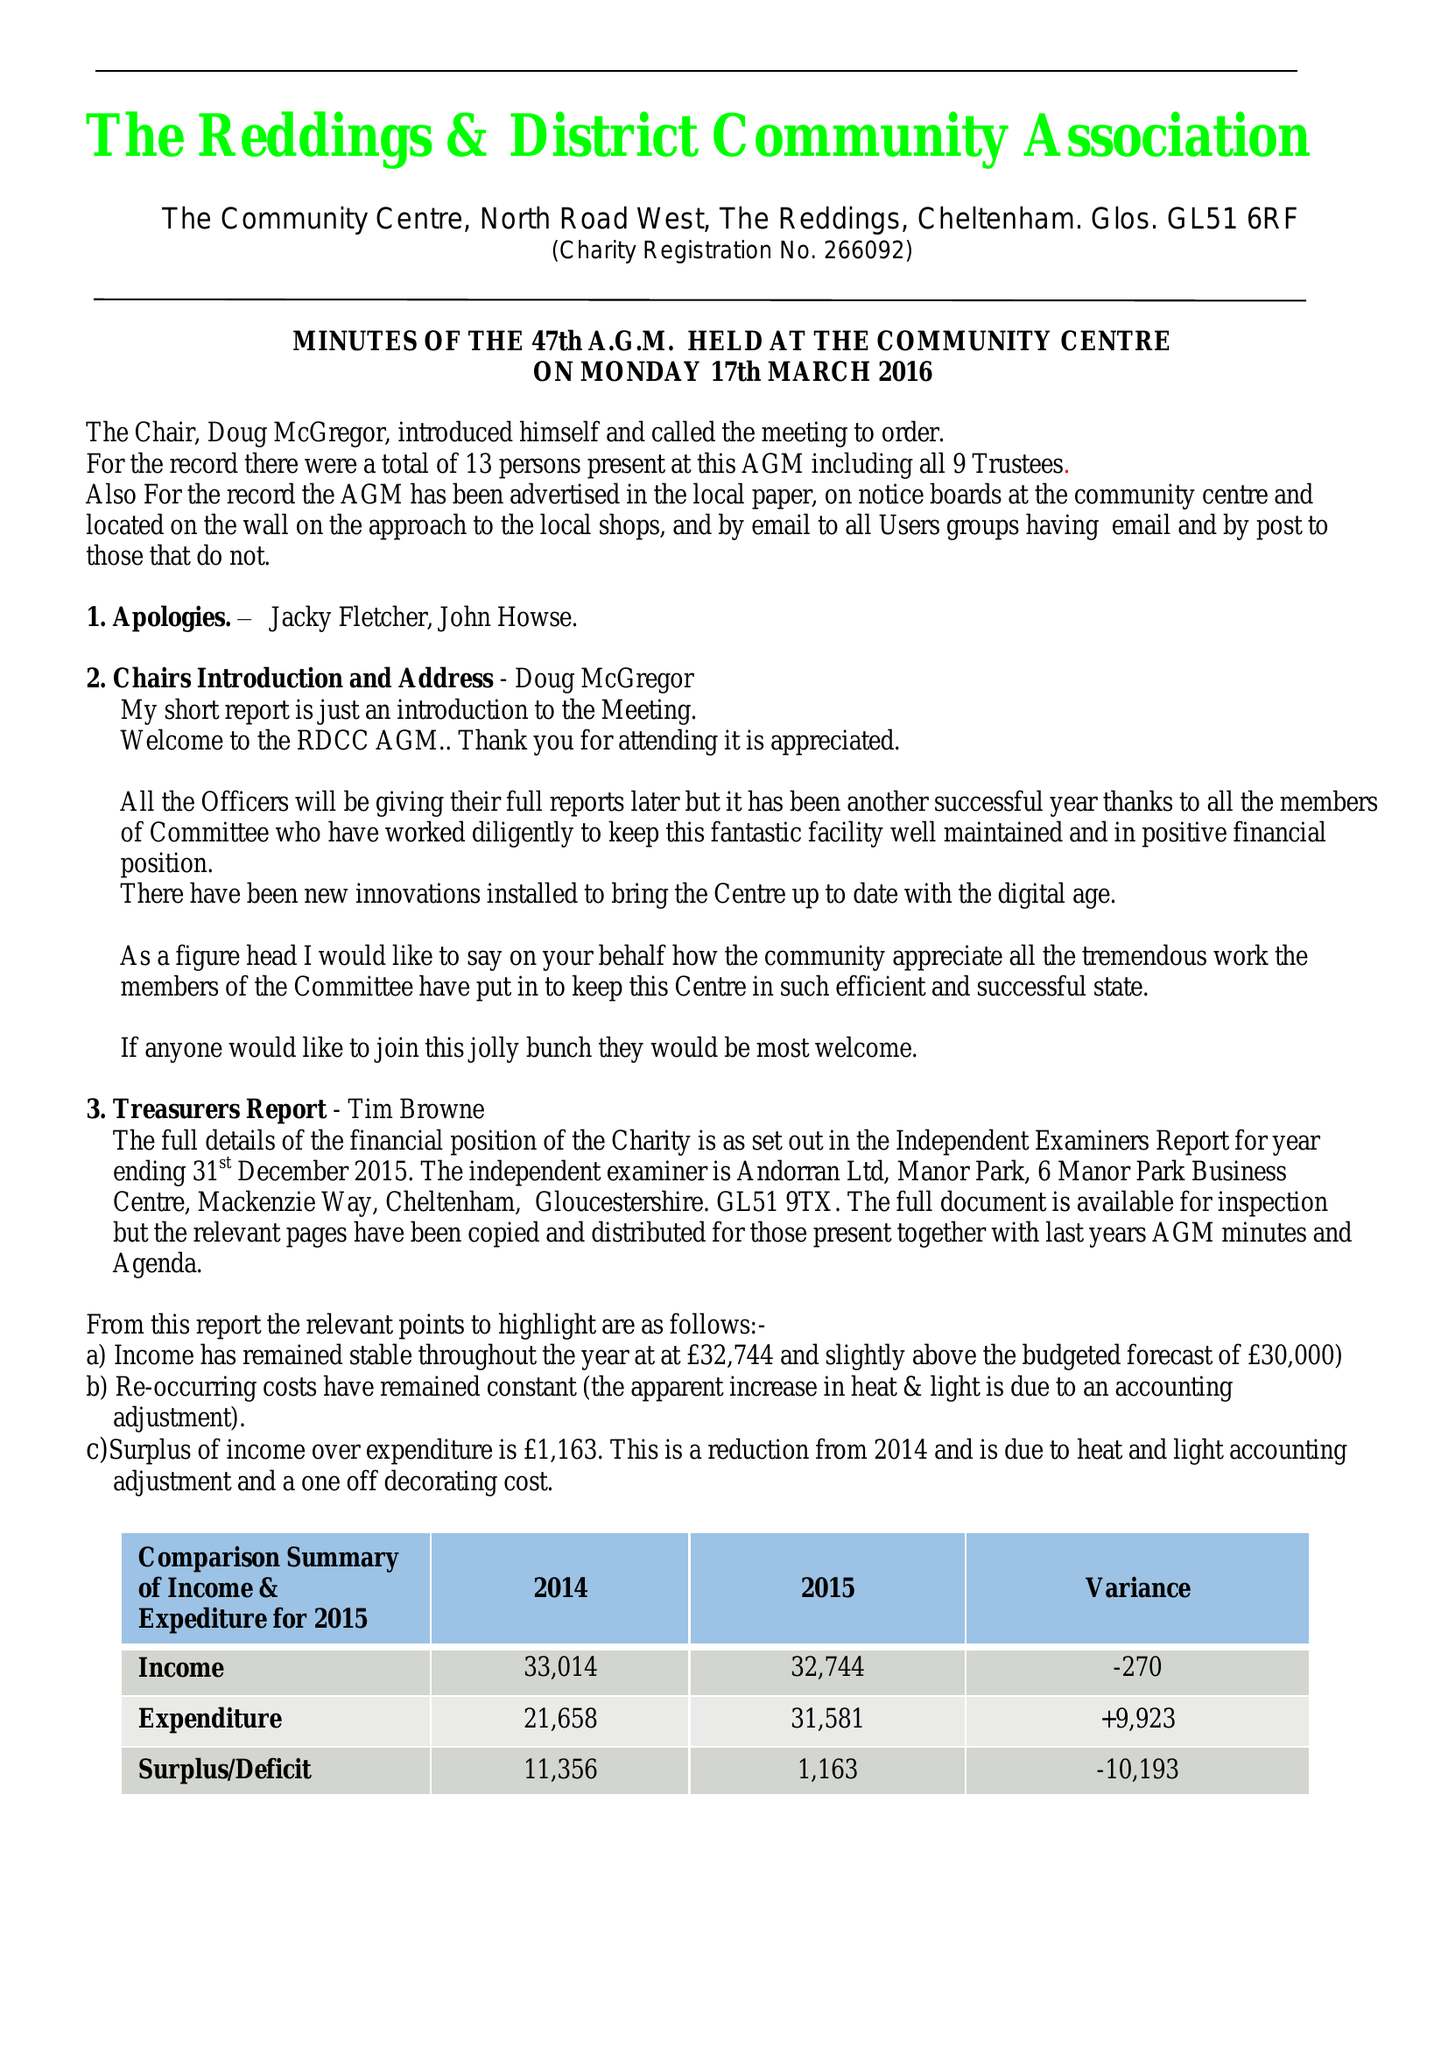What is the value for the charity_name?
Answer the question using a single word or phrase. Reddings and District Community Association 